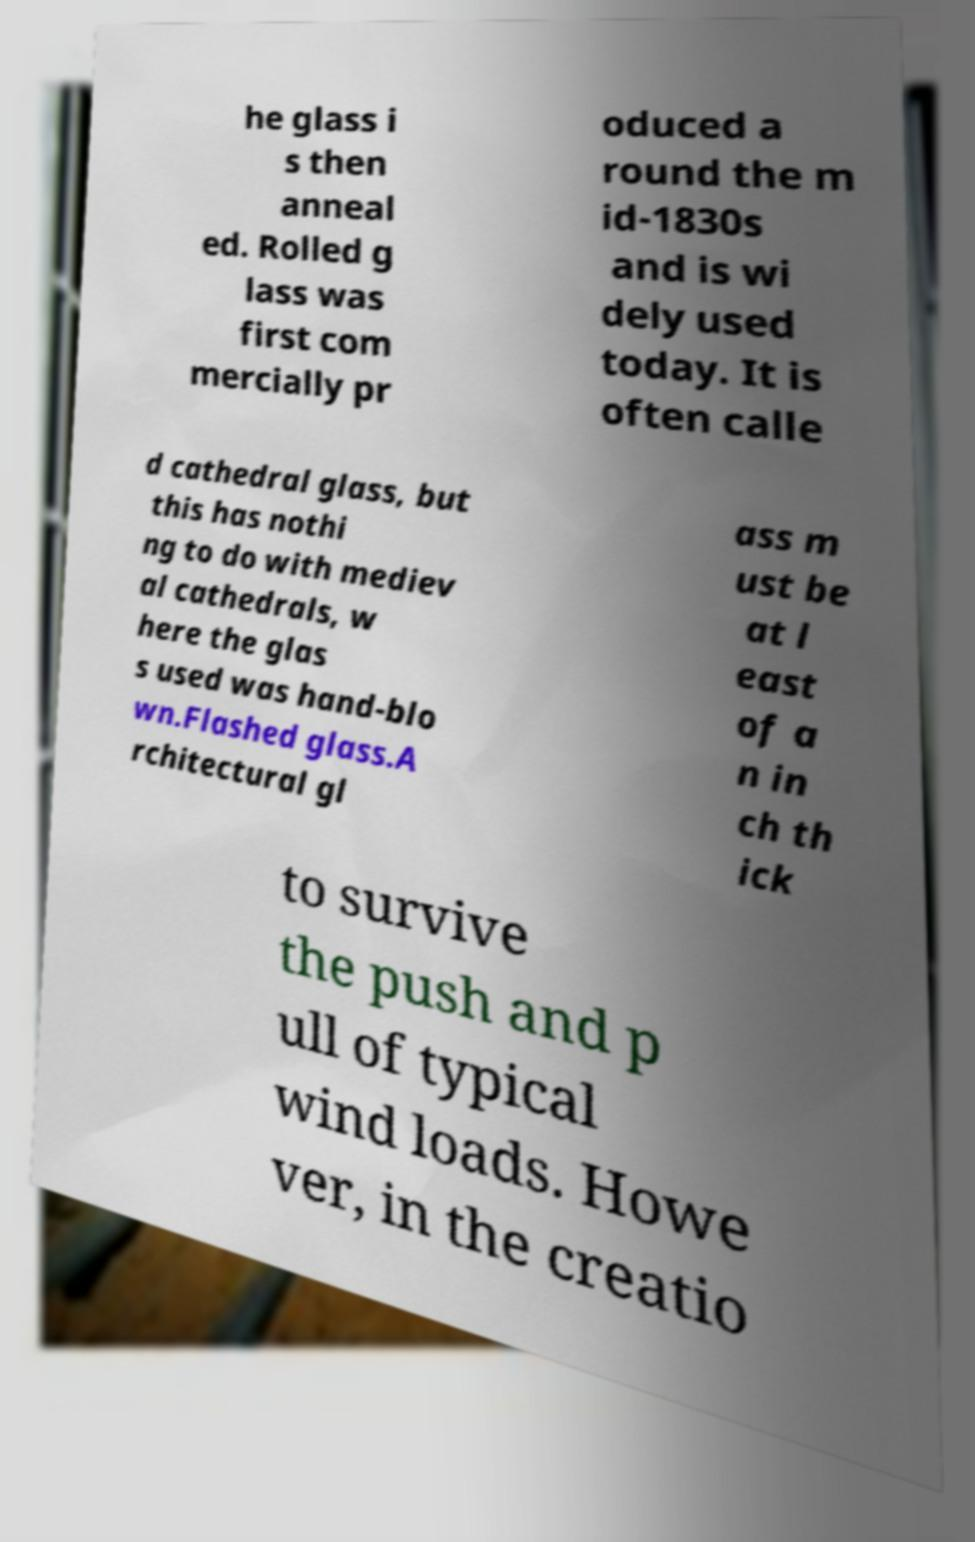Please read and relay the text visible in this image. What does it say? he glass i s then anneal ed. Rolled g lass was first com mercially pr oduced a round the m id-1830s and is wi dely used today. It is often calle d cathedral glass, but this has nothi ng to do with mediev al cathedrals, w here the glas s used was hand-blo wn.Flashed glass.A rchitectural gl ass m ust be at l east of a n in ch th ick to survive the push and p ull of typical wind loads. Howe ver, in the creatio 